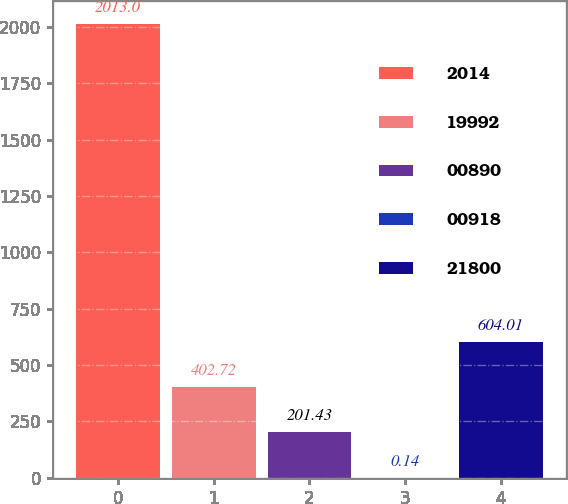Convert chart to OTSL. <chart><loc_0><loc_0><loc_500><loc_500><bar_chart><fcel>2014<fcel>19992<fcel>00890<fcel>00918<fcel>21800<nl><fcel>2013<fcel>402.72<fcel>201.43<fcel>0.14<fcel>604.01<nl></chart> 